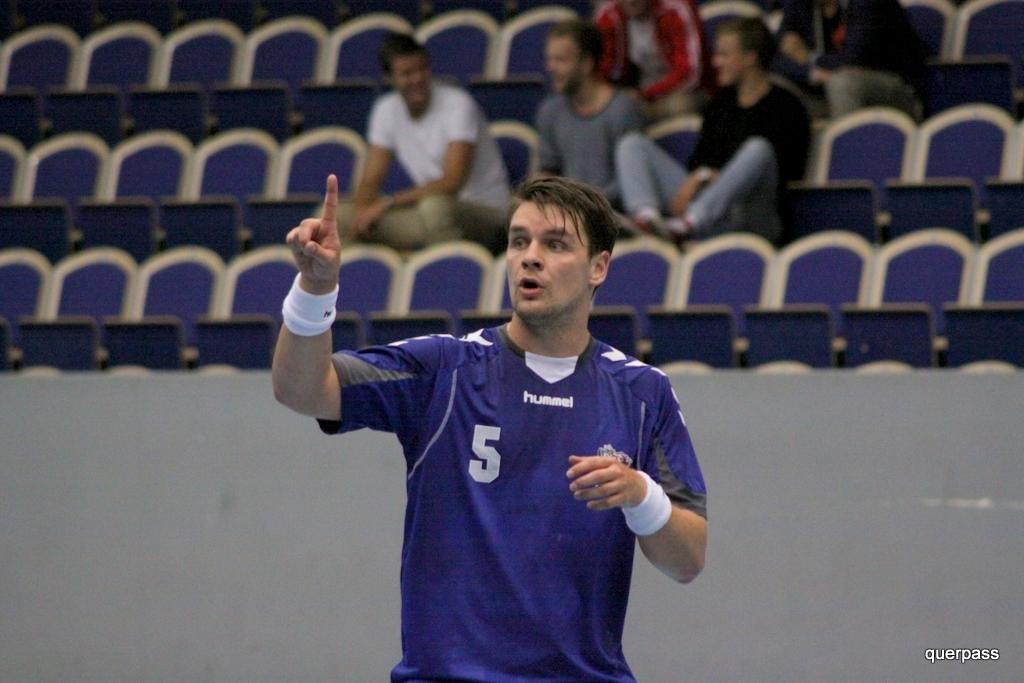What can be seen in the image? There are people and chairs in the image. Can you describe the clothing of one of the people? The person standing in the front is wearing a blue color t-shirt. What type of leather material can be seen on the chairs in the image? There is no mention of leather material in the image; the chairs are not described in detail. 